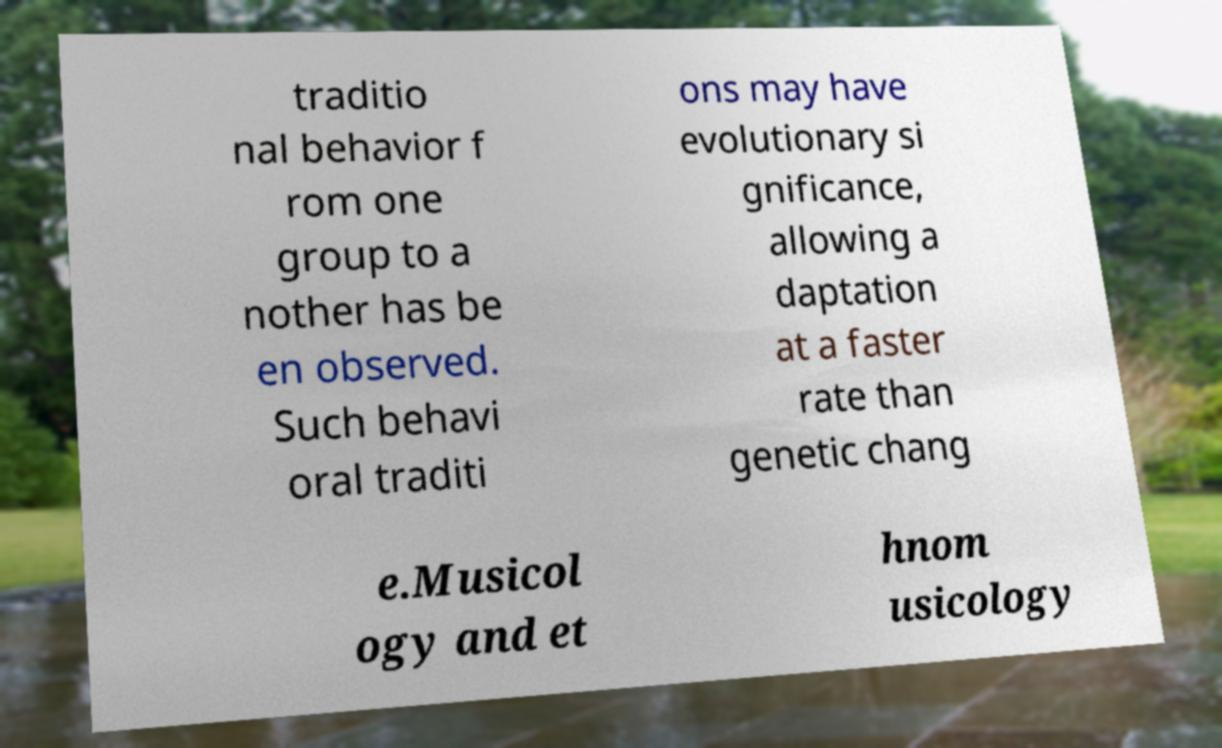Please read and relay the text visible in this image. What does it say? traditio nal behavior f rom one group to a nother has be en observed. Such behavi oral traditi ons may have evolutionary si gnificance, allowing a daptation at a faster rate than genetic chang e.Musicol ogy and et hnom usicology 